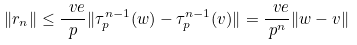<formula> <loc_0><loc_0><loc_500><loc_500>\| r _ { n } \| \leq \frac { \ v e } { p } \| \tau _ { p } ^ { n - 1 } ( w ) - \tau _ { p } ^ { n - 1 } ( v ) \| = \frac { \ v e } { p ^ { n } } \| w - v \|</formula> 